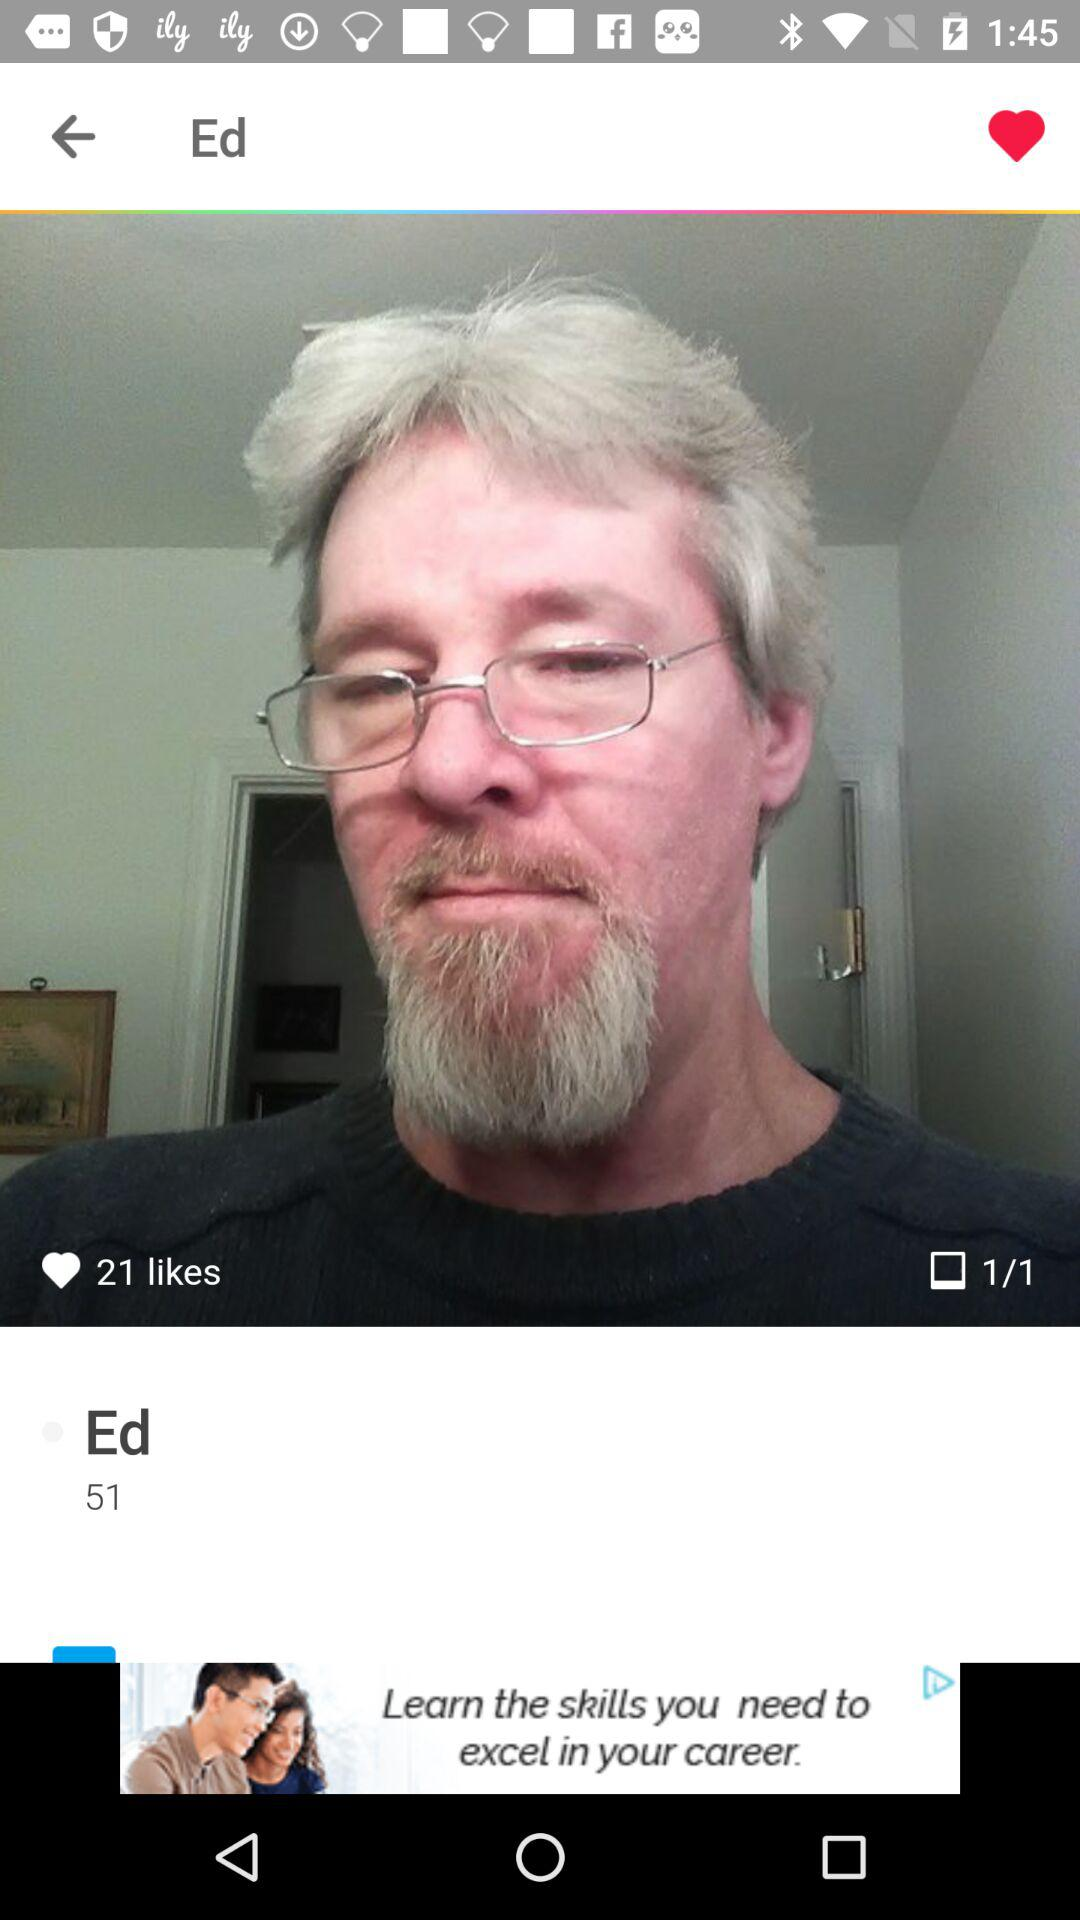What is the total number of images? The total number of images is 1. 